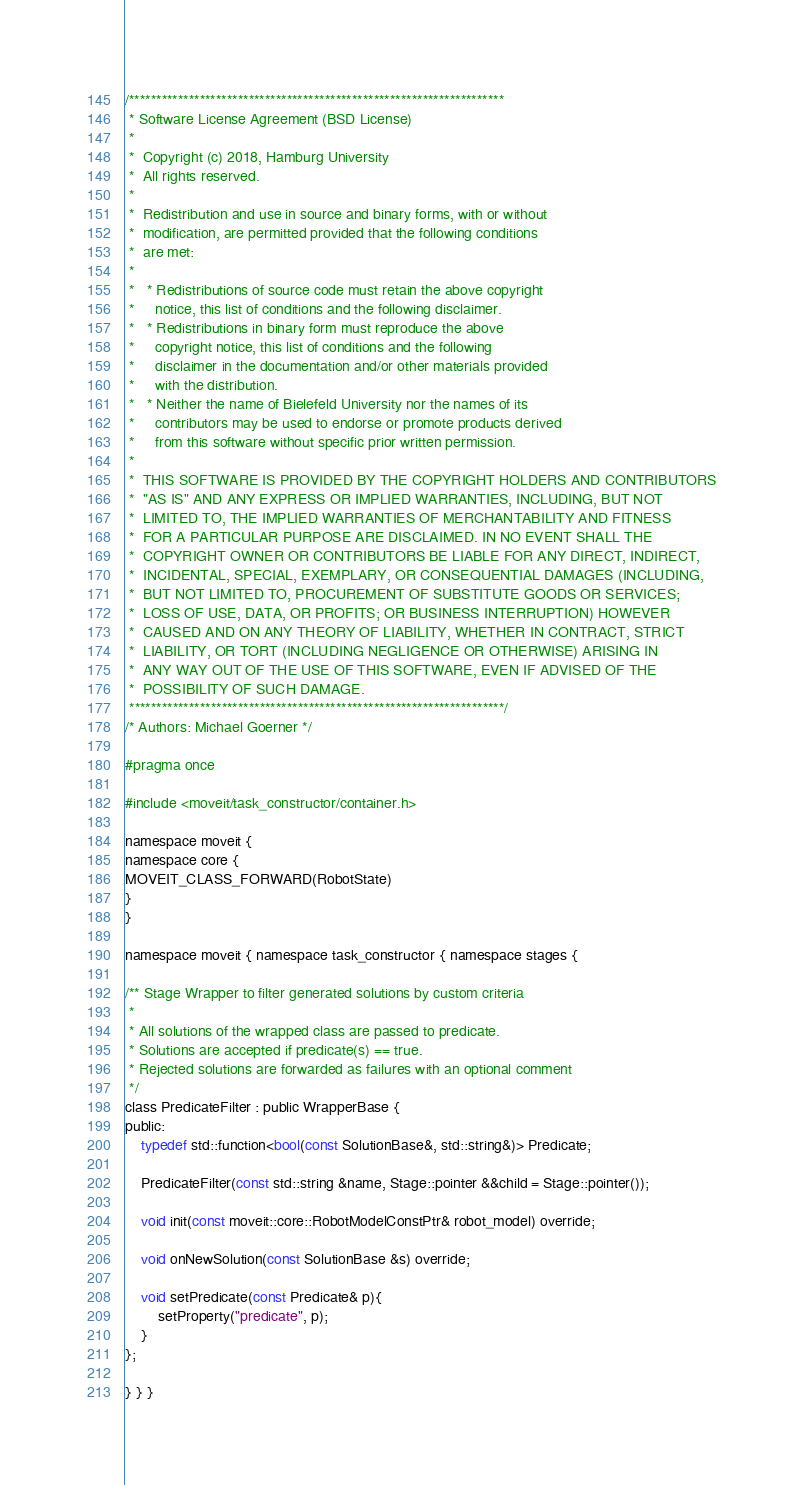<code> <loc_0><loc_0><loc_500><loc_500><_C_>/*********************************************************************
 * Software License Agreement (BSD License)
 *
 *  Copyright (c) 2018, Hamburg University
 *  All rights reserved.
 *
 *  Redistribution and use in source and binary forms, with or without
 *  modification, are permitted provided that the following conditions
 *  are met:
 *
 *   * Redistributions of source code must retain the above copyright
 *     notice, this list of conditions and the following disclaimer.
 *   * Redistributions in binary form must reproduce the above
 *     copyright notice, this list of conditions and the following
 *     disclaimer in the documentation and/or other materials provided
 *     with the distribution.
 *   * Neither the name of Bielefeld University nor the names of its
 *     contributors may be used to endorse or promote products derived
 *     from this software without specific prior written permission.
 *
 *  THIS SOFTWARE IS PROVIDED BY THE COPYRIGHT HOLDERS AND CONTRIBUTORS
 *  "AS IS" AND ANY EXPRESS OR IMPLIED WARRANTIES, INCLUDING, BUT NOT
 *  LIMITED TO, THE IMPLIED WARRANTIES OF MERCHANTABILITY AND FITNESS
 *  FOR A PARTICULAR PURPOSE ARE DISCLAIMED. IN NO EVENT SHALL THE
 *  COPYRIGHT OWNER OR CONTRIBUTORS BE LIABLE FOR ANY DIRECT, INDIRECT,
 *  INCIDENTAL, SPECIAL, EXEMPLARY, OR CONSEQUENTIAL DAMAGES (INCLUDING,
 *  BUT NOT LIMITED TO, PROCUREMENT OF SUBSTITUTE GOODS OR SERVICES;
 *  LOSS OF USE, DATA, OR PROFITS; OR BUSINESS INTERRUPTION) HOWEVER
 *  CAUSED AND ON ANY THEORY OF LIABILITY, WHETHER IN CONTRACT, STRICT
 *  LIABILITY, OR TORT (INCLUDING NEGLIGENCE OR OTHERWISE) ARISING IN
 *  ANY WAY OUT OF THE USE OF THIS SOFTWARE, EVEN IF ADVISED OF THE
 *  POSSIBILITY OF SUCH DAMAGE.
 *********************************************************************/
/* Authors: Michael Goerner */

#pragma once

#include <moveit/task_constructor/container.h>

namespace moveit {
namespace core {
MOVEIT_CLASS_FORWARD(RobotState)
}
}

namespace moveit { namespace task_constructor { namespace stages {

/** Stage Wrapper to filter generated solutions by custom criteria
 *
 * All solutions of the wrapped class are passed to predicate.
 * Solutions are accepted if predicate(s) == true.
 * Rejected solutions are forwarded as failures with an optional comment
 */
class PredicateFilter : public WrapperBase {
public:
	typedef std::function<bool(const SolutionBase&, std::string&)> Predicate;

	PredicateFilter(const std::string &name, Stage::pointer &&child = Stage::pointer());

	void init(const moveit::core::RobotModelConstPtr& robot_model) override;

	void onNewSolution(const SolutionBase &s) override;

	void setPredicate(const Predicate& p){
		setProperty("predicate", p);
	}
};

} } }
</code> 